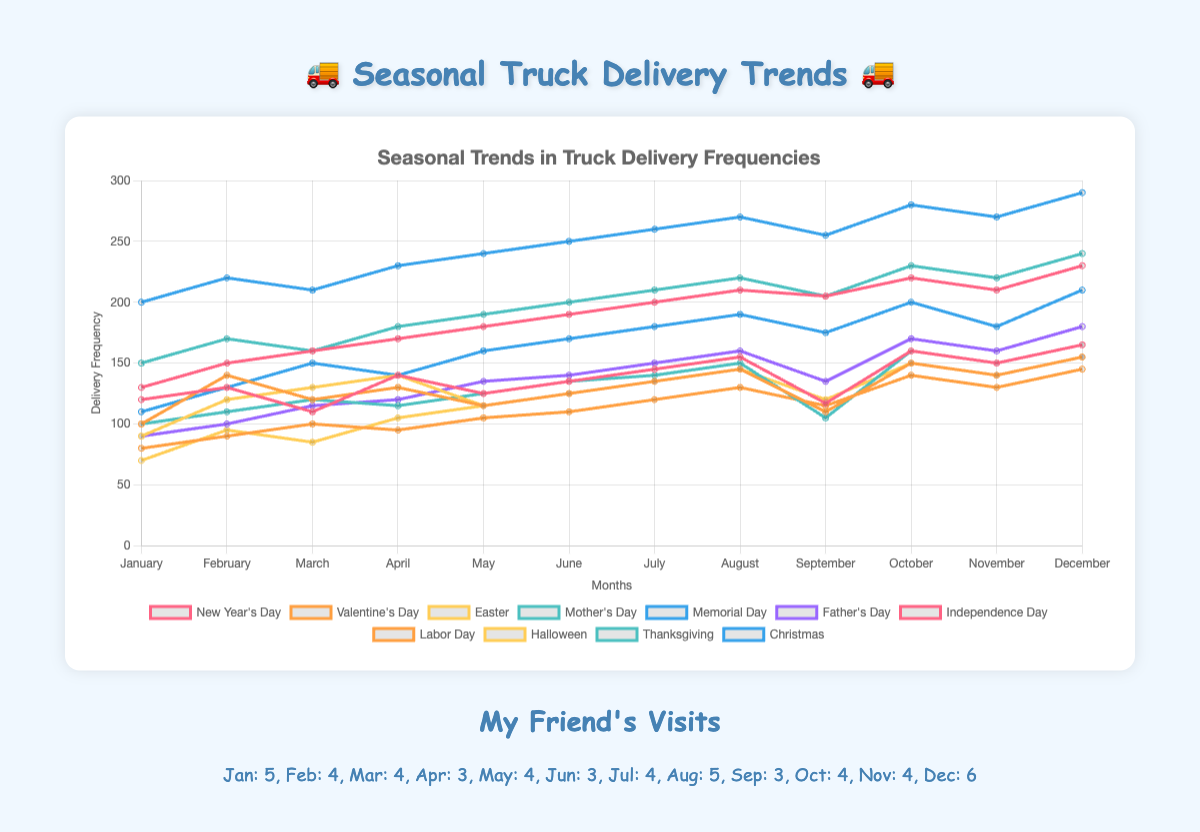What month has the highest truck delivery frequency for Christmas? The data shows the delivery frequencies for each holiday across different months. Looking specifically at the line labeled "Christmas," the highest point corresponds to a delivery frequency of 290. Looking at the x-axis, this point falls on December. Therefore, December has the highest truck delivery frequency for Christmas.
Answer: December Which event causes the highest spike in delivery frequencies and what month does it occur? Looking for the highest spike in the line plot across all holidays, the highest point corresponds to a delivery frequency of 290 for Christmas in December.
Answer: Christmas in December Compare the delivery frequencies between Independence Day and Memorial Day in July. Which one is higher and by how much? Checking the data on the line plot for July, the delivery frequency for Independence Day is 200, and for Memorial Day, it is 180. The difference between these two values is 200 - 180 = 20.
Answer: Independence Day by 20 What is the average delivery frequency for Thanksgiving across the highlighted months? The values for Thanksgiving are 150, 170, 160, 180, 190, 200, 210, 220, 205, 230, 220, and 240. To find the average: sum these values (150+170+160+180+190+200+210+220+205+230+220+240 = 2375) and divide by the number of months, which is 12. 2375 / 12 = 197.92.
Answer: 197.92 How do the delivery frequencies for New Year's Day change from January to February? Observing the line labeled "New Year's Day", the delivery frequency starts at 120 in January and rises to 130 in February. The difference is 130 - 120 = 10.
Answer: Increase by 10 Which month sees the lowest delivery frequency for Halloween? Referring to the line labeled "Halloween," the lowest point is 70. By looking at the corresponding month on the x-axis, it falls in January.
Answer: January During which month(s) do all holidays show the highest delivery frequencies? Reviewing each line, the highest points for multiple holidays occur in December. This includes New Year's Day, Valentine's Day, Mother's Day, and Christmas, among others.
Answer: December What is the median value of truck deliveries for Mother's Day? Listing the values for Mother's Day: 100, 110, 120, 115, 125, 135, 140, 150, 105, 160, 150, and 165. Placing them in order: 100, 105, 110, 115, 120, 125, 135, 140, 150, 150, 160, 165. The median is the average of the 6th and 7th values: (125 + 135) / 2 = 130.
Answer: 130 